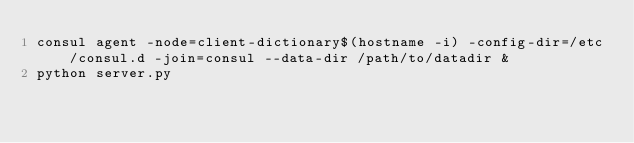<code> <loc_0><loc_0><loc_500><loc_500><_Bash_>consul agent -node=client-dictionary$(hostname -i) -config-dir=/etc/consul.d -join=consul --data-dir /path/to/datadir &
python server.py</code> 